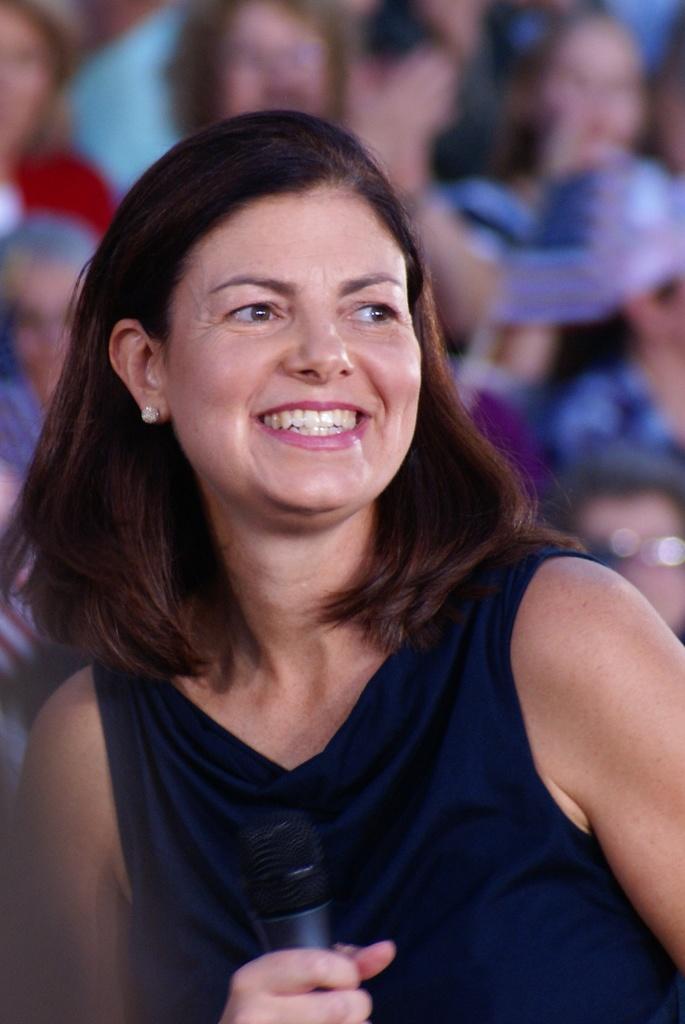In one or two sentences, can you explain what this image depicts? The woman in front of the picture wearing black T-shirt is holding a microphone in her hand. She is smiling. Behind her, we see people sitting. It is blurred in the background. 